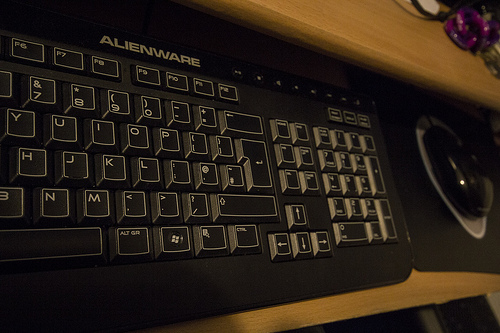Describe the overall aesthetic of the workspace. The workspace provides a minimalist aesthetic with a focus on functionality, featuring dark tones and a sleek design consistent with modern gaming setups. 